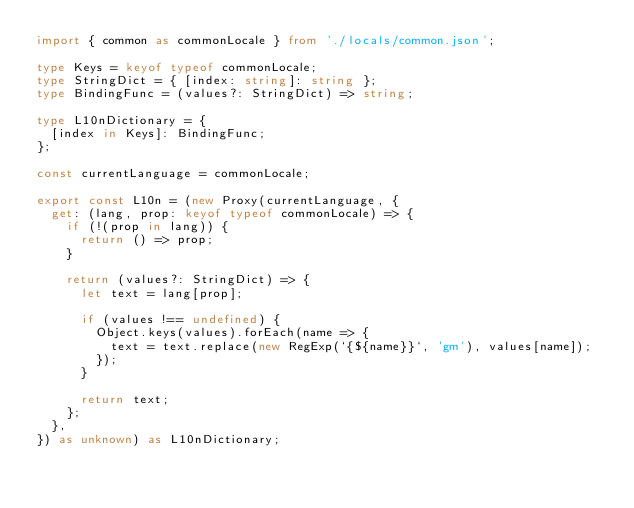Convert code to text. <code><loc_0><loc_0><loc_500><loc_500><_TypeScript_>import { common as commonLocale } from './locals/common.json';

type Keys = keyof typeof commonLocale;
type StringDict = { [index: string]: string };
type BindingFunc = (values?: StringDict) => string;

type L10nDictionary = {
  [index in Keys]: BindingFunc;
};

const currentLanguage = commonLocale;

export const L10n = (new Proxy(currentLanguage, {
  get: (lang, prop: keyof typeof commonLocale) => {
    if (!(prop in lang)) {
      return () => prop;
    }

    return (values?: StringDict) => {
      let text = lang[prop];

      if (values !== undefined) {
        Object.keys(values).forEach(name => {
          text = text.replace(new RegExp(`{${name}}`, 'gm'), values[name]);
        });
      }

      return text;
    };
  },
}) as unknown) as L10nDictionary;
</code> 